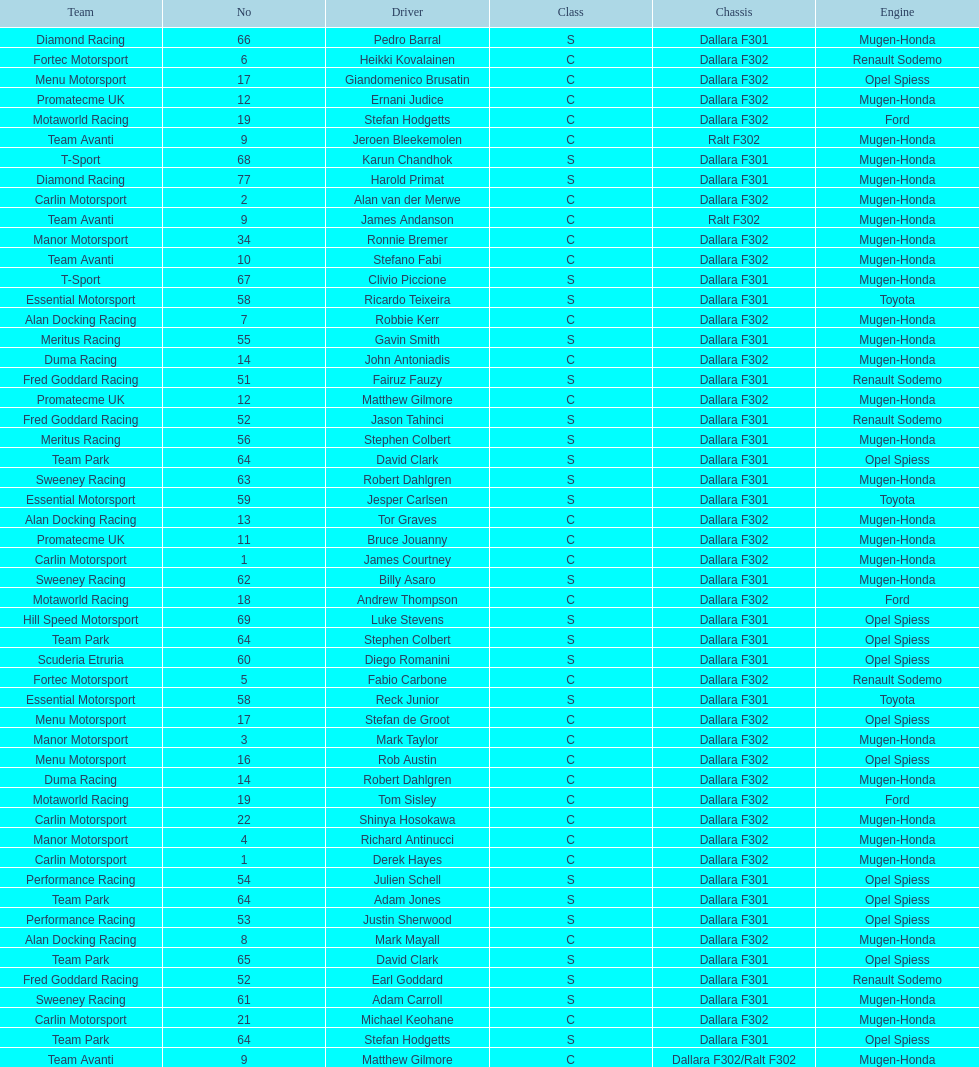The two drivers on t-sport are clivio piccione and what other driver? Karun Chandhok. 